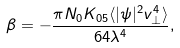Convert formula to latex. <formula><loc_0><loc_0><loc_500><loc_500>\beta = - \frac { \pi N _ { 0 } K _ { 0 5 } \langle | \psi | ^ { 2 } v _ { \perp } ^ { 4 } \rangle } { 6 4 \lambda ^ { 4 } } ,</formula> 